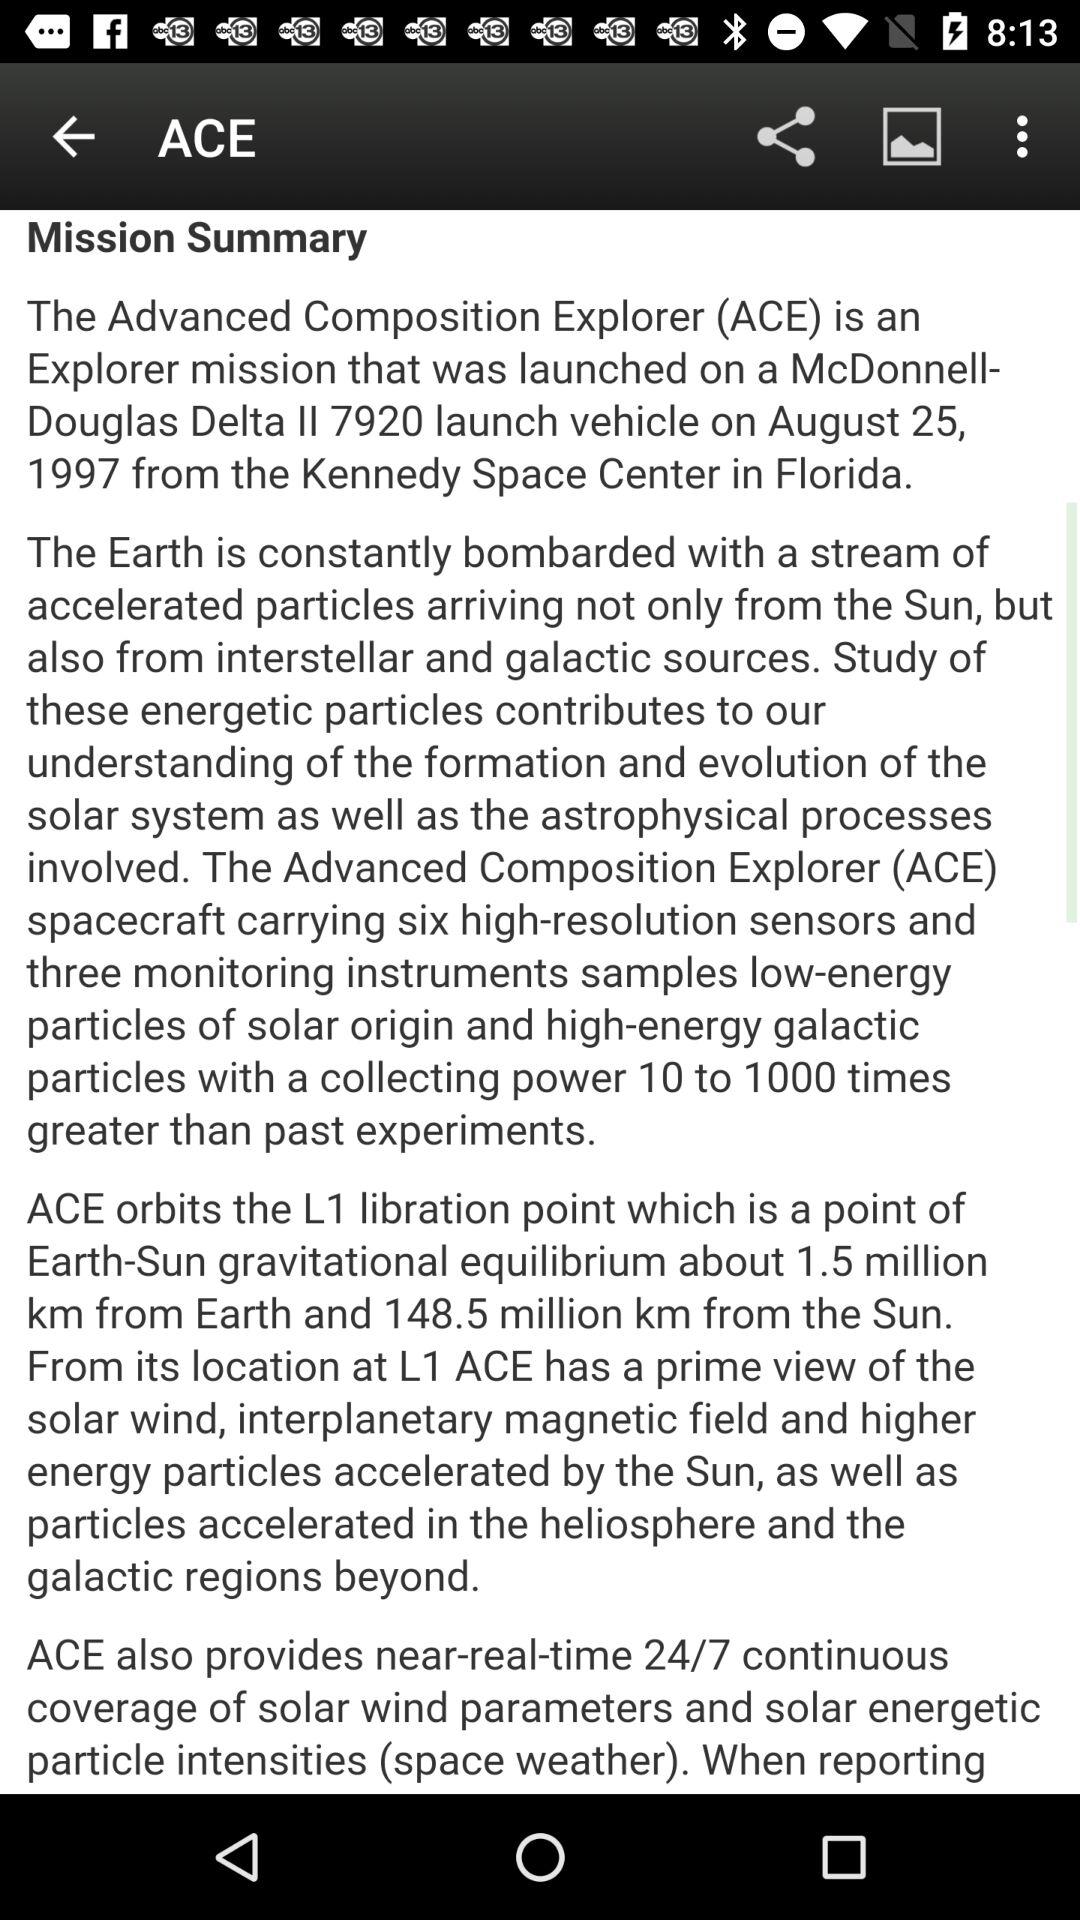What real time coverage is provided by the ACE? ACE provides real time coverage of solar wind parameters and solar energetic particle intensities (space weather). 